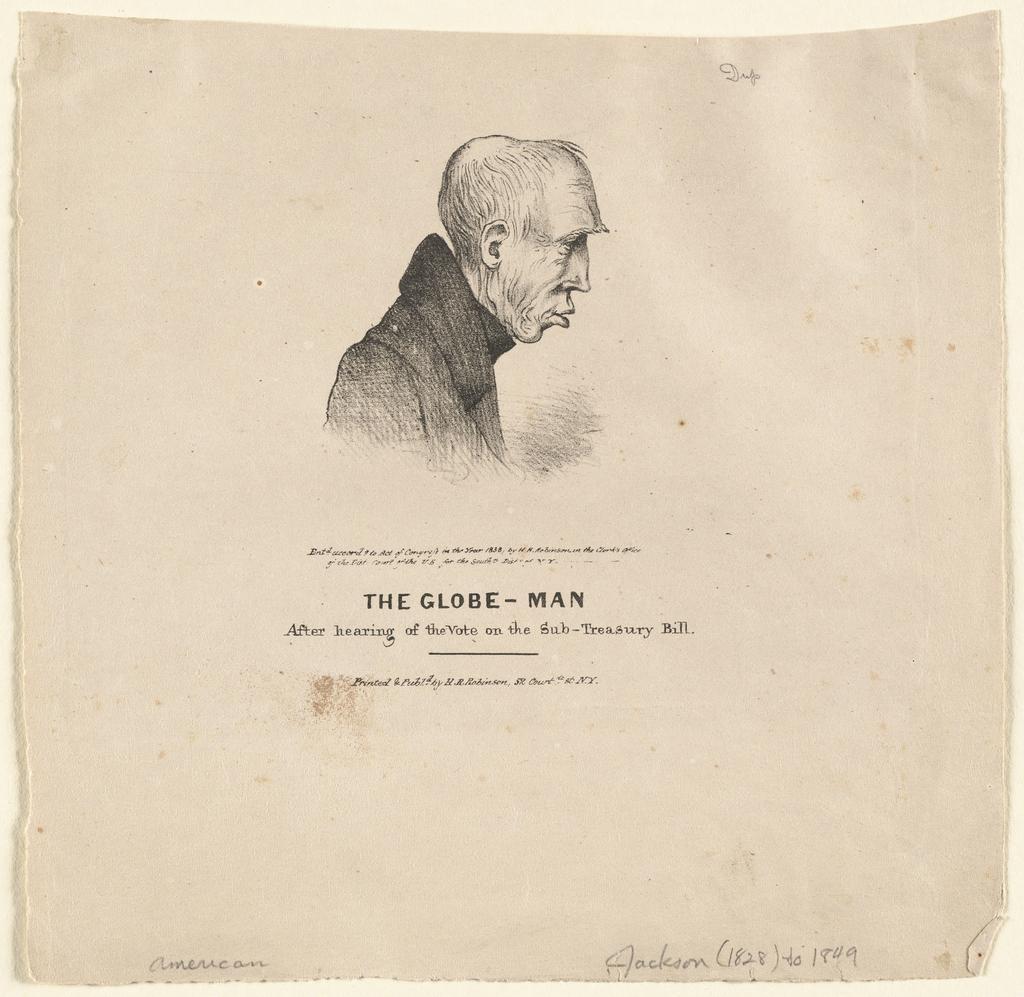Describe this image in one or two sentences. In this picture we can see a poster, in this poster we can see a person and text. 